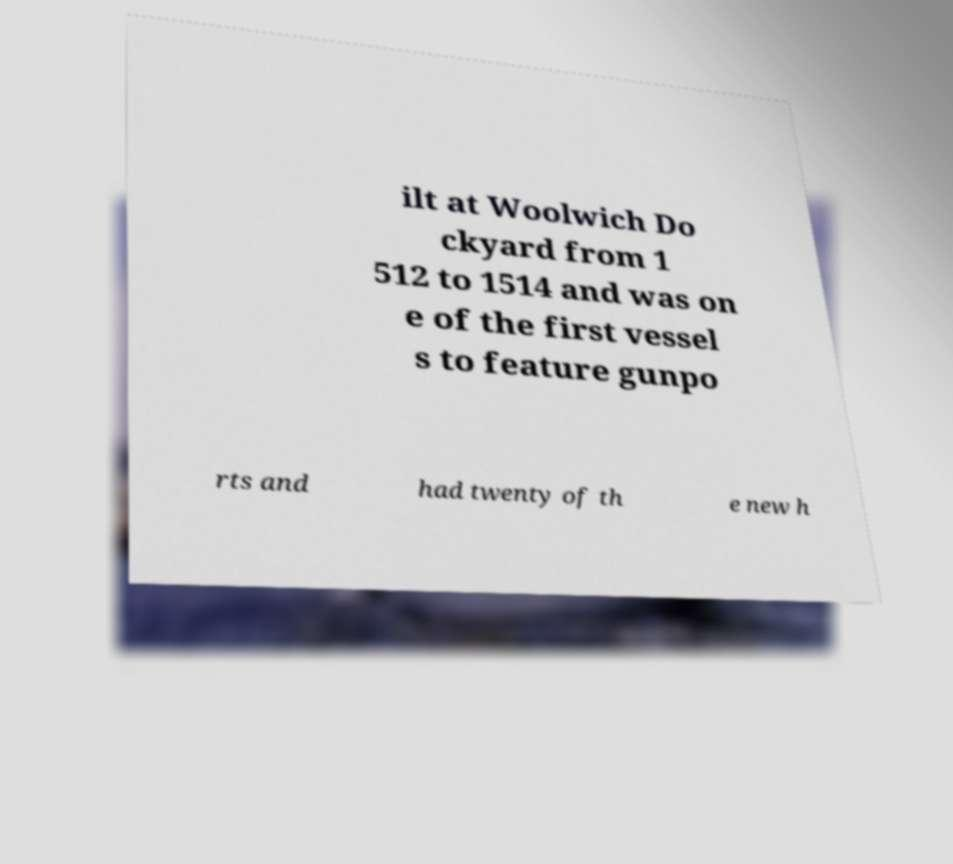Please identify and transcribe the text found in this image. ilt at Woolwich Do ckyard from 1 512 to 1514 and was on e of the first vessel s to feature gunpo rts and had twenty of th e new h 